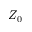Convert formula to latex. <formula><loc_0><loc_0><loc_500><loc_500>Z _ { 0 }</formula> 